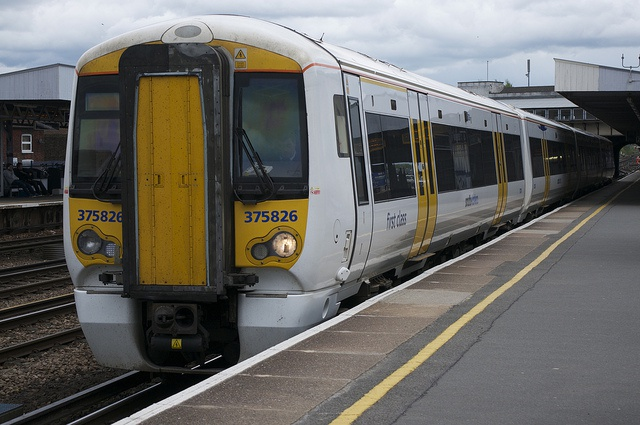Describe the objects in this image and their specific colors. I can see train in darkgray, black, gray, and olive tones, people in darkgray, purple, darkblue, blue, and black tones, people in darkgray and black tones, people in black and darkgray tones, and people in black and darkgray tones in this image. 